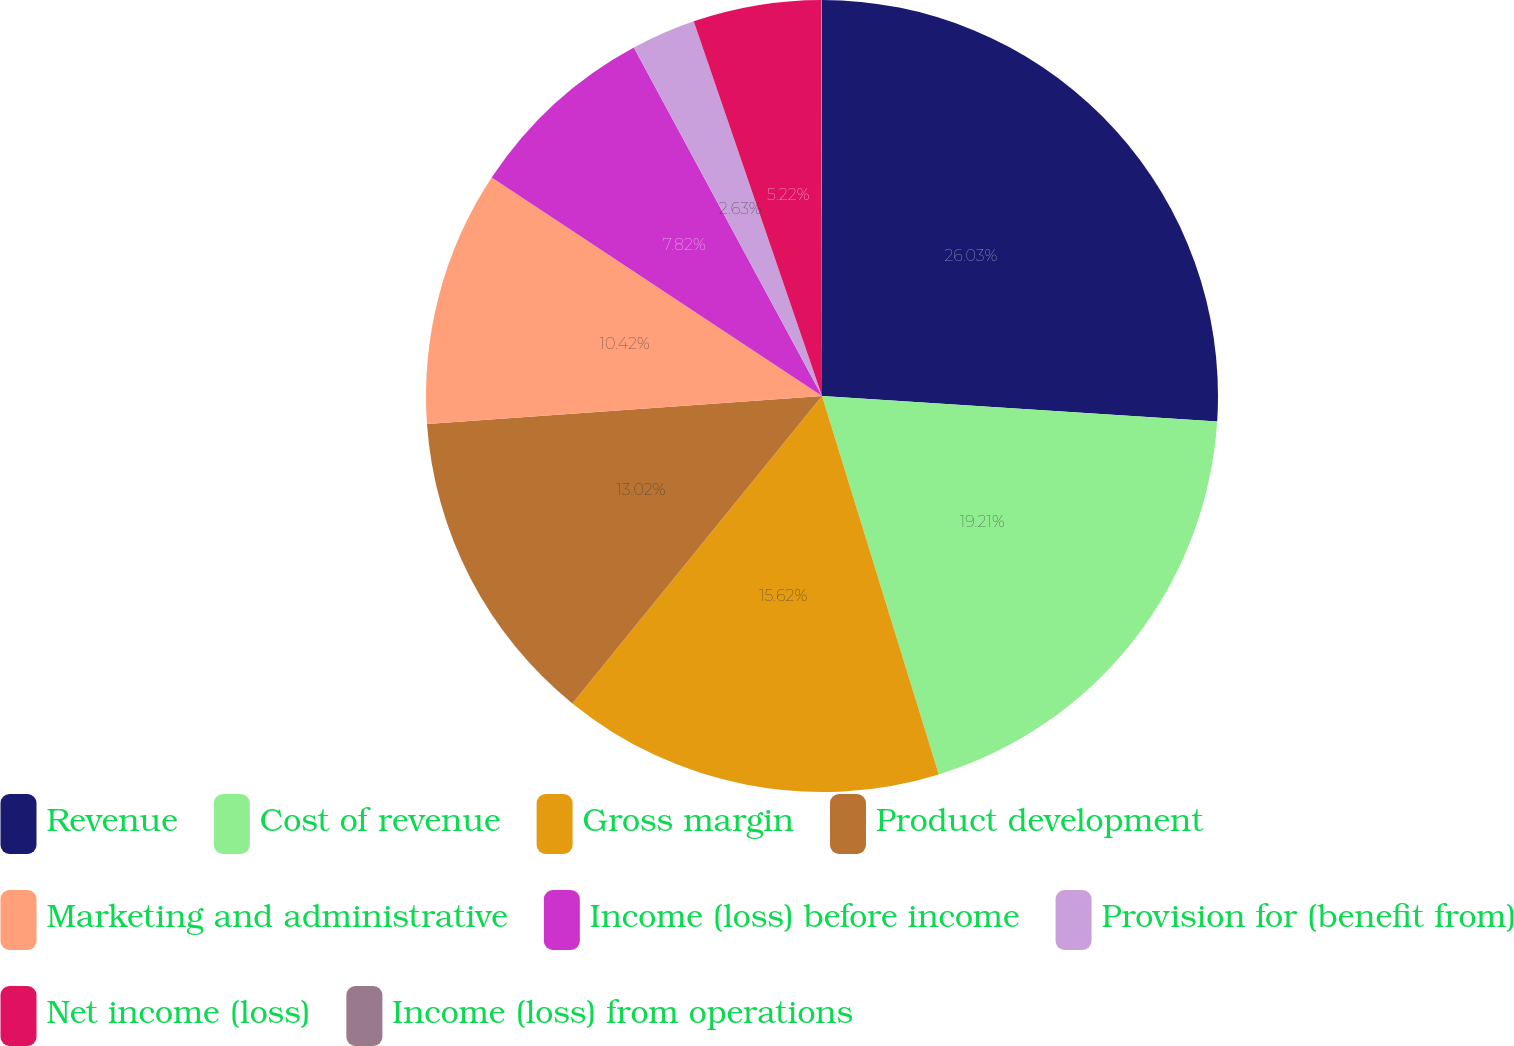Convert chart. <chart><loc_0><loc_0><loc_500><loc_500><pie_chart><fcel>Revenue<fcel>Cost of revenue<fcel>Gross margin<fcel>Product development<fcel>Marketing and administrative<fcel>Income (loss) before income<fcel>Provision for (benefit from)<fcel>Net income (loss)<fcel>Income (loss) from operations<nl><fcel>26.02%<fcel>19.21%<fcel>15.62%<fcel>13.02%<fcel>10.42%<fcel>7.82%<fcel>2.63%<fcel>5.22%<fcel>0.03%<nl></chart> 